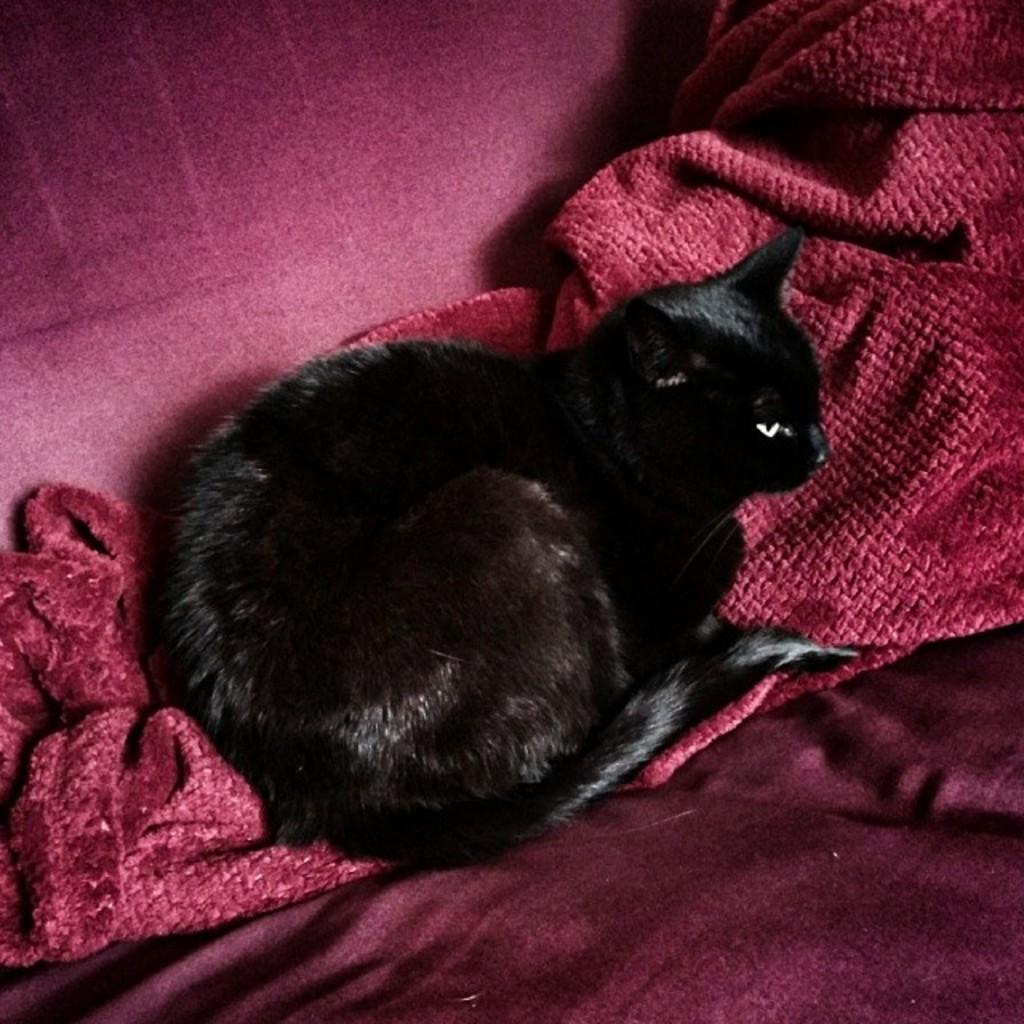How would you summarize this image in a sentence or two? In this image we can see a cat laying on the cloth. 